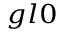<formula> <loc_0><loc_0><loc_500><loc_500>_ { g l 0 }</formula> 